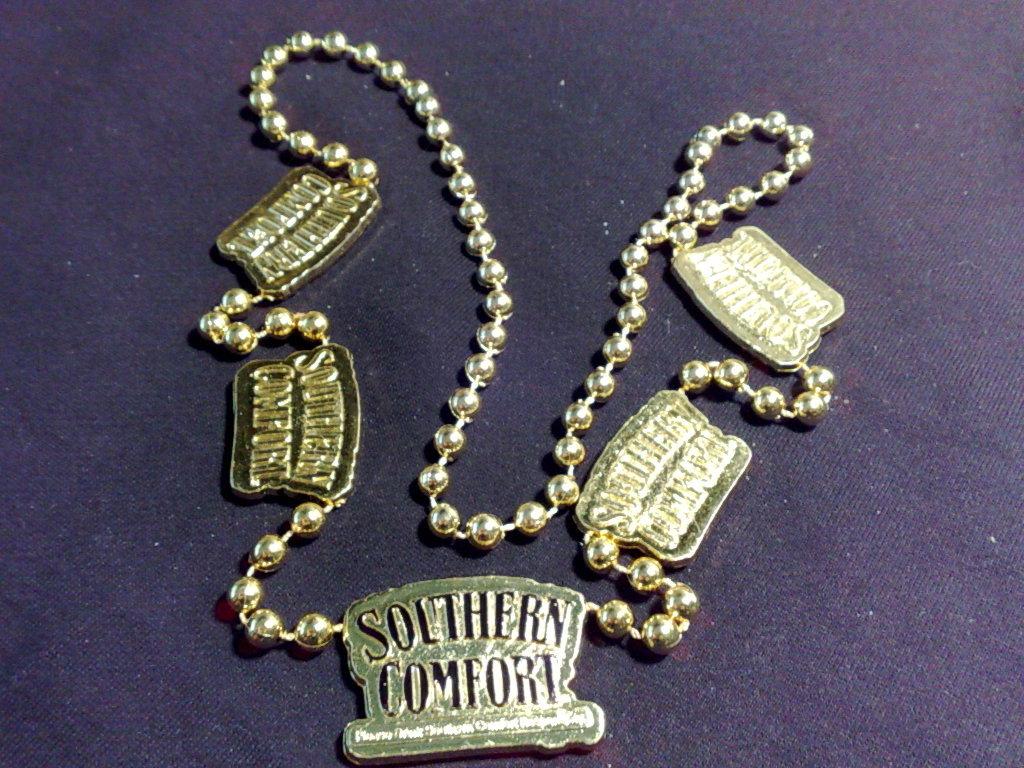What do the white letters say?
Your answer should be compact. Southern comfort. What do the charms say?
Offer a terse response. Southern comfort. 